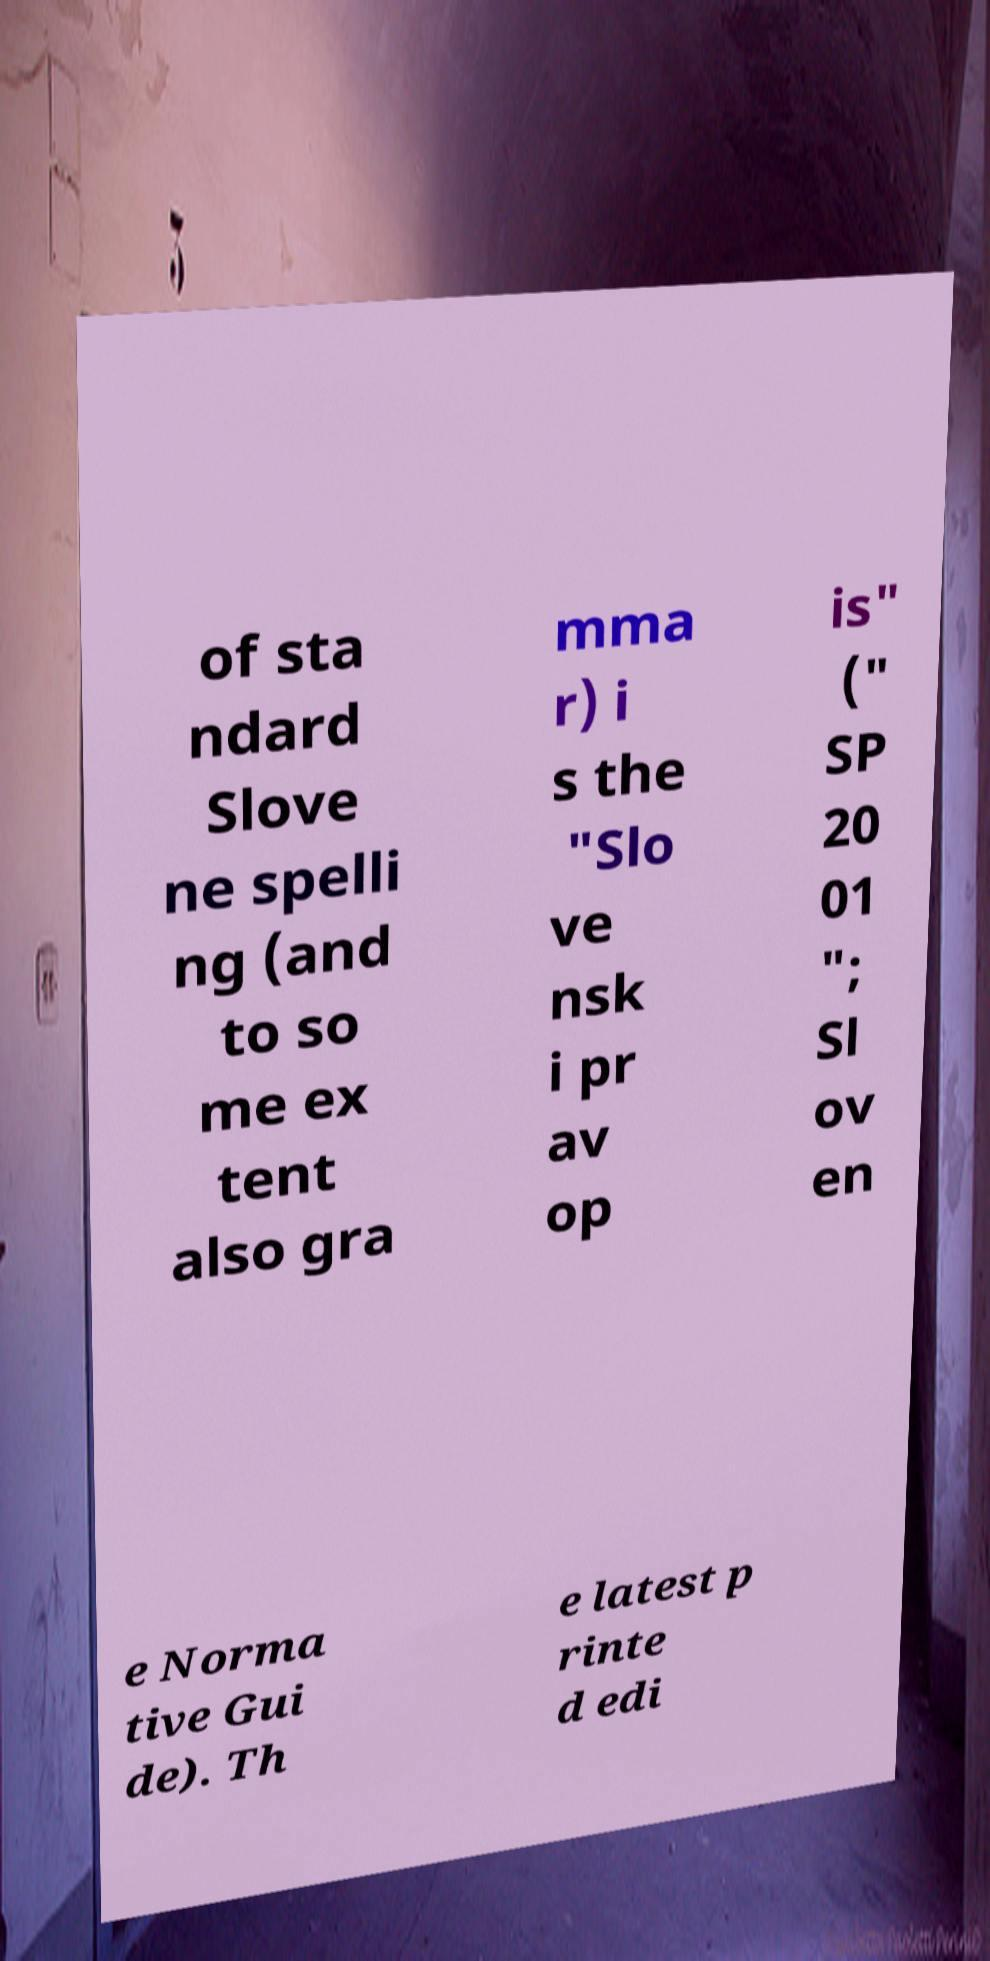Can you read and provide the text displayed in the image?This photo seems to have some interesting text. Can you extract and type it out for me? of sta ndard Slove ne spelli ng (and to so me ex tent also gra mma r) i s the "Slo ve nsk i pr av op is" (" SP 20 01 "; Sl ov en e Norma tive Gui de). Th e latest p rinte d edi 